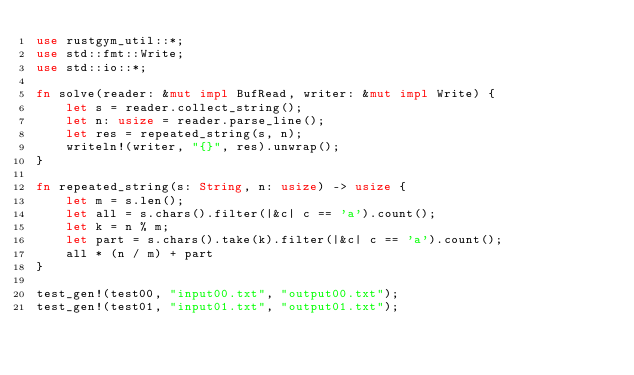<code> <loc_0><loc_0><loc_500><loc_500><_Rust_>use rustgym_util::*;
use std::fmt::Write;
use std::io::*;

fn solve(reader: &mut impl BufRead, writer: &mut impl Write) {
    let s = reader.collect_string();
    let n: usize = reader.parse_line();
    let res = repeated_string(s, n);
    writeln!(writer, "{}", res).unwrap();
}

fn repeated_string(s: String, n: usize) -> usize {
    let m = s.len();
    let all = s.chars().filter(|&c| c == 'a').count();
    let k = n % m;
    let part = s.chars().take(k).filter(|&c| c == 'a').count();
    all * (n / m) + part
}

test_gen!(test00, "input00.txt", "output00.txt");
test_gen!(test01, "input01.txt", "output01.txt");
</code> 